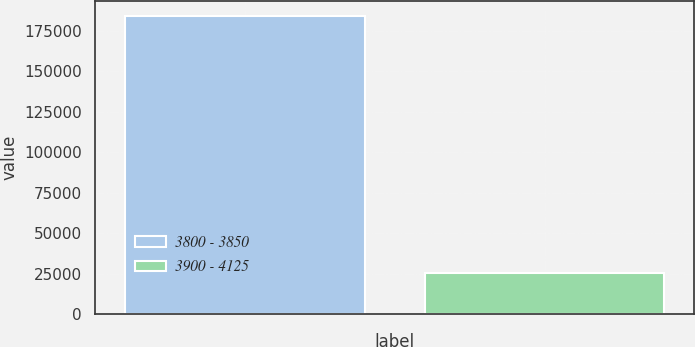Convert chart. <chart><loc_0><loc_0><loc_500><loc_500><bar_chart><fcel>3800 - 3850<fcel>3900 - 4125<nl><fcel>184241<fcel>25586<nl></chart> 